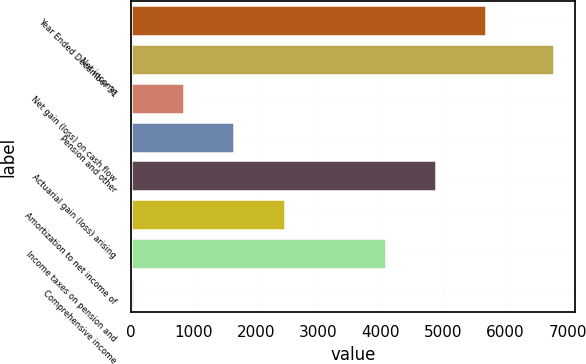Convert chart to OTSL. <chart><loc_0><loc_0><loc_500><loc_500><bar_chart><fcel>Year Ended December 31<fcel>Net income<fcel>Net gain (loss) on cash flow<fcel>Pension and other<fcel>Actuarial gain (loss) arising<fcel>Amortization to net income of<fcel>Income taxes on pension and<fcel>Comprehensive income<nl><fcel>5688.2<fcel>6774<fcel>848.6<fcel>1655.2<fcel>4881.6<fcel>2461.8<fcel>4075<fcel>42<nl></chart> 